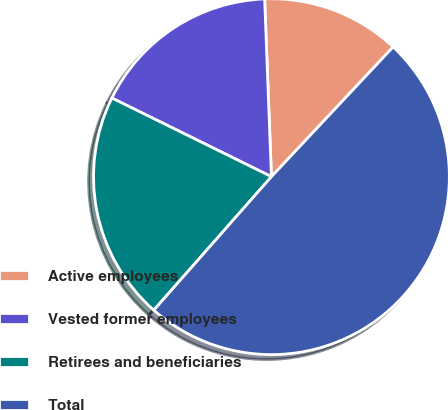Convert chart to OTSL. <chart><loc_0><loc_0><loc_500><loc_500><pie_chart><fcel>Active employees<fcel>Vested former employees<fcel>Retirees and beneficiaries<fcel>Total<nl><fcel>12.6%<fcel>17.1%<fcel>20.79%<fcel>49.5%<nl></chart> 